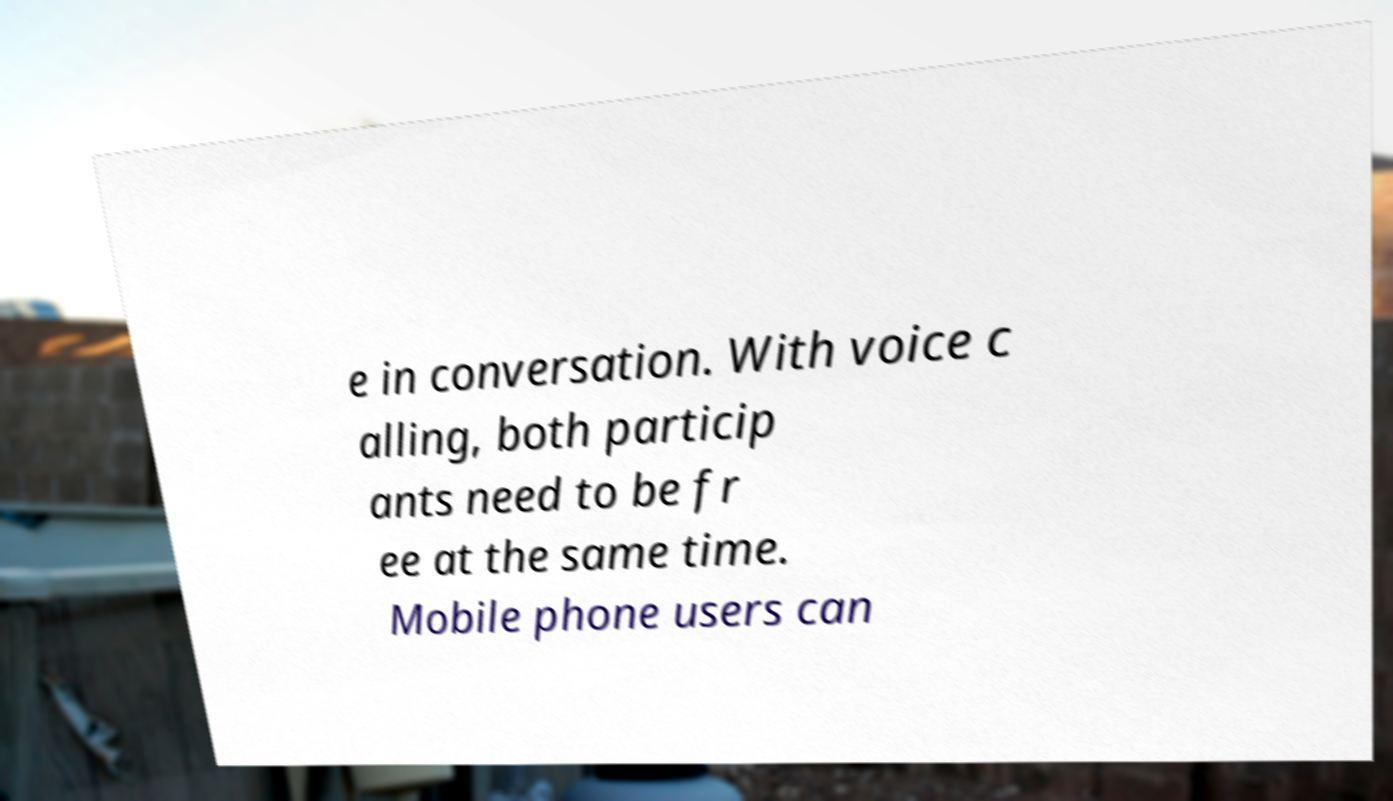What messages or text are displayed in this image? I need them in a readable, typed format. e in conversation. With voice c alling, both particip ants need to be fr ee at the same time. Mobile phone users can 